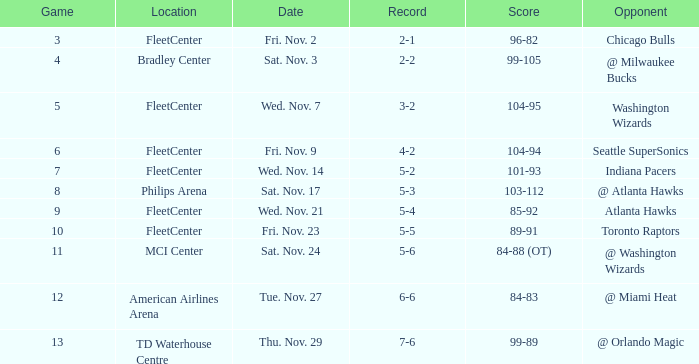What is the earliest game with a score of 99-89? 13.0. 